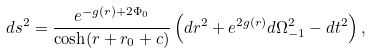Convert formula to latex. <formula><loc_0><loc_0><loc_500><loc_500>d s ^ { 2 } = \frac { e ^ { - g ( r ) + 2 \Phi _ { 0 } } } { \cosh ( r + r _ { 0 } + c ) } \left ( d r ^ { 2 } + e ^ { 2 g ( r ) } d \Omega _ { - 1 } ^ { 2 } - d t ^ { 2 } \right ) ,</formula> 